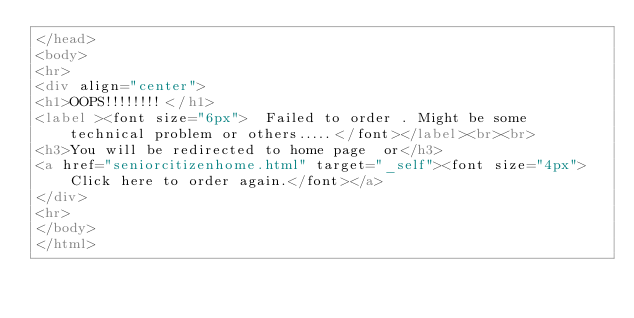Convert code to text. <code><loc_0><loc_0><loc_500><loc_500><_HTML_></head>
<body>
<hr>
<div align="center">
<h1>OOPS!!!!!!!!</h1>
<label ><font size="6px">  Failed to order . Might be some technical problem or others.....</font></label><br><br>
<h3>You will be redirected to home page  or</h3>
<a href="seniorcitizenhome.html" target="_self"><font size="4px">Click here to order again.</font></a>
</div>
<hr>
</body>
</html>



</code> 